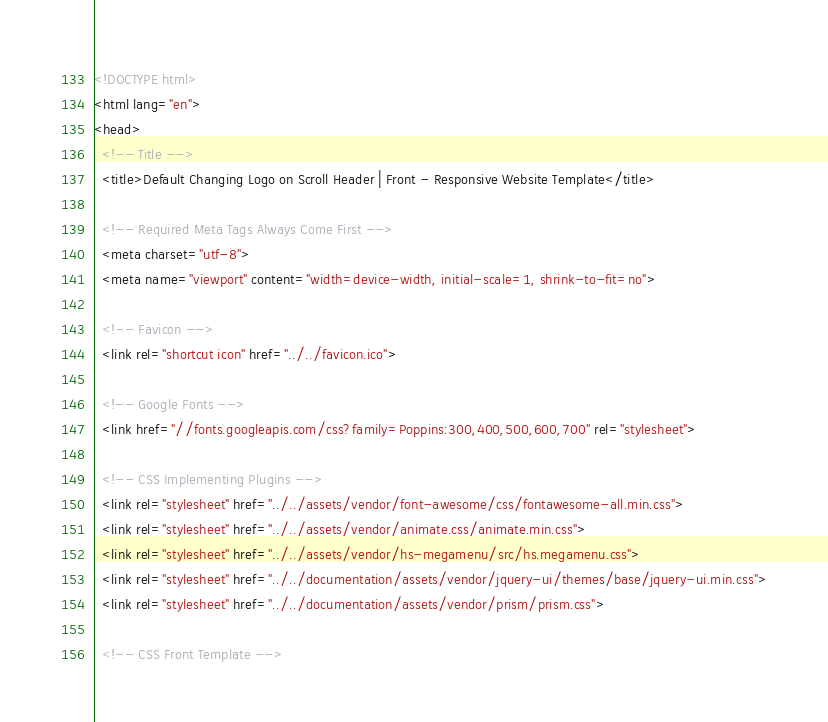<code> <loc_0><loc_0><loc_500><loc_500><_HTML_><!DOCTYPE html>
<html lang="en">
<head>
  <!-- Title -->
  <title>Default Changing Logo on Scroll Header | Front - Responsive Website Template</title>

  <!-- Required Meta Tags Always Come First -->
  <meta charset="utf-8">
  <meta name="viewport" content="width=device-width, initial-scale=1, shrink-to-fit=no">

  <!-- Favicon -->
  <link rel="shortcut icon" href="../../favicon.ico">

  <!-- Google Fonts -->
  <link href="//fonts.googleapis.com/css?family=Poppins:300,400,500,600,700" rel="stylesheet">

  <!-- CSS Implementing Plugins -->
  <link rel="stylesheet" href="../../assets/vendor/font-awesome/css/fontawesome-all.min.css">
  <link rel="stylesheet" href="../../assets/vendor/animate.css/animate.min.css">
  <link rel="stylesheet" href="../../assets/vendor/hs-megamenu/src/hs.megamenu.css">
  <link rel="stylesheet" href="../../documentation/assets/vendor/jquery-ui/themes/base/jquery-ui.min.css">
  <link rel="stylesheet" href="../../documentation/assets/vendor/prism/prism.css">

  <!-- CSS Front Template --></code> 